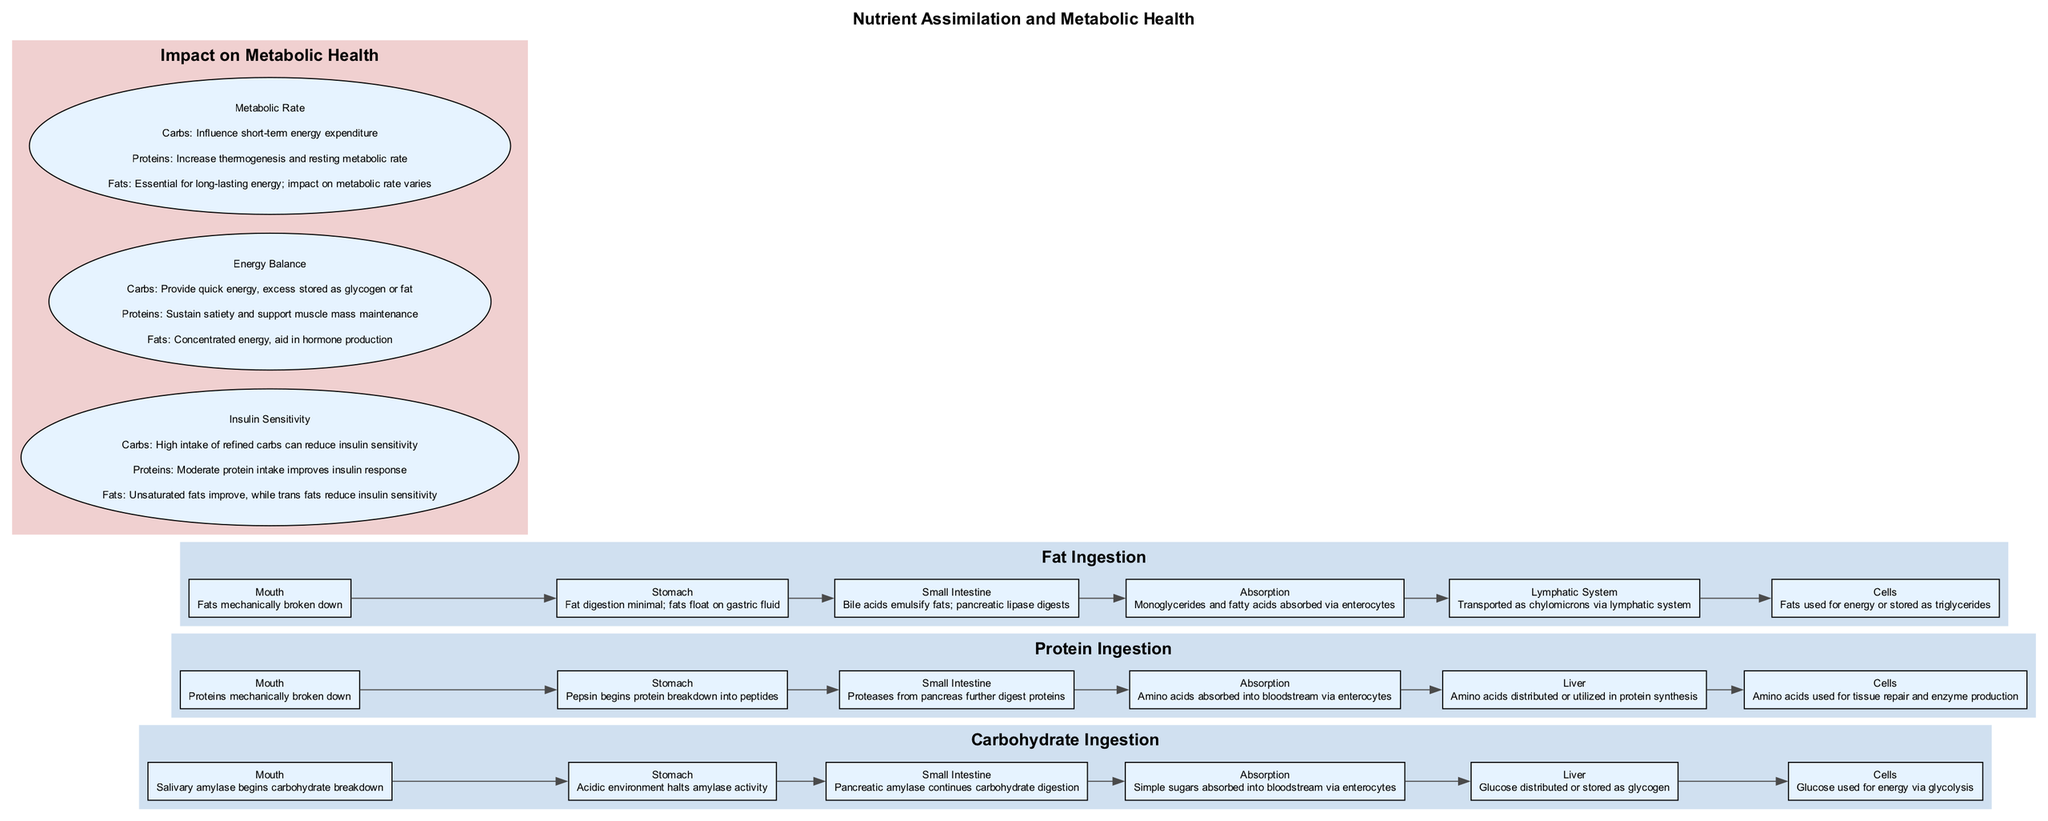What is the first step in carbohydrate ingestion? The first step in carbohydrate ingestion is the entry of carbohydrates into the digestive system, starting at the mouth where salivary amylase begins the carbohydrate breakdown.
Answer: Salivary amylase begins carbohydrate breakdown Which organ is primarily involved in protein breakdown? The stomach is primarily involved in protein breakdown, where pepsin begins to break proteins into peptides.
Answer: Stomach How many nodes are in the Fat Ingestion block? The Fat Ingestion block contains 6 nodes which depict the different elements involved in the fat metabolism process: Mouth, Stomach, Small Intestine, Absorption, Lymphatic System, and Cells.
Answer: 6 What is the impact of unsaturated fats on insulin sensitivity? Unsaturated fats improve insulin sensitivity according to the impact section in the diagram, while trans fats reduce it.
Answer: Improve What resources are utilized for energy after protein ingestion? After protein ingestion, amino acids are utilized for tissue repair and enzyme production, showing how proteins support bodily functions.
Answer: Tissue repair and enzyme production Which nutrient provides quick energy? Carbohydrates provide quick energy, as indicated in the Energy Balance impact section of the diagram.
Answer: Carbohydrates How many absorption processes are detailed in the diagram? The diagram details three absorption processes: Simple sugars from carbohydrates, amino acids from proteins, and monoglycerides and fatty acids from fats, all absorbed via enterocytes.
Answer: 3 What is the main function of monoglycerides and fatty acids in cells? In cells, monoglycerides and fatty acids are used for energy or stored as triglycerides, illustrating their dual role in metabolism.
Answer: Used for energy or stored as triglycerides Which macronutrient intake is suggested to improve insulin response? Moderate protein intake is suggested to improve insulin response according to the impact section of the diagram, showing the beneficial effect of balanced protein consumption.
Answer: Moderate protein intake 